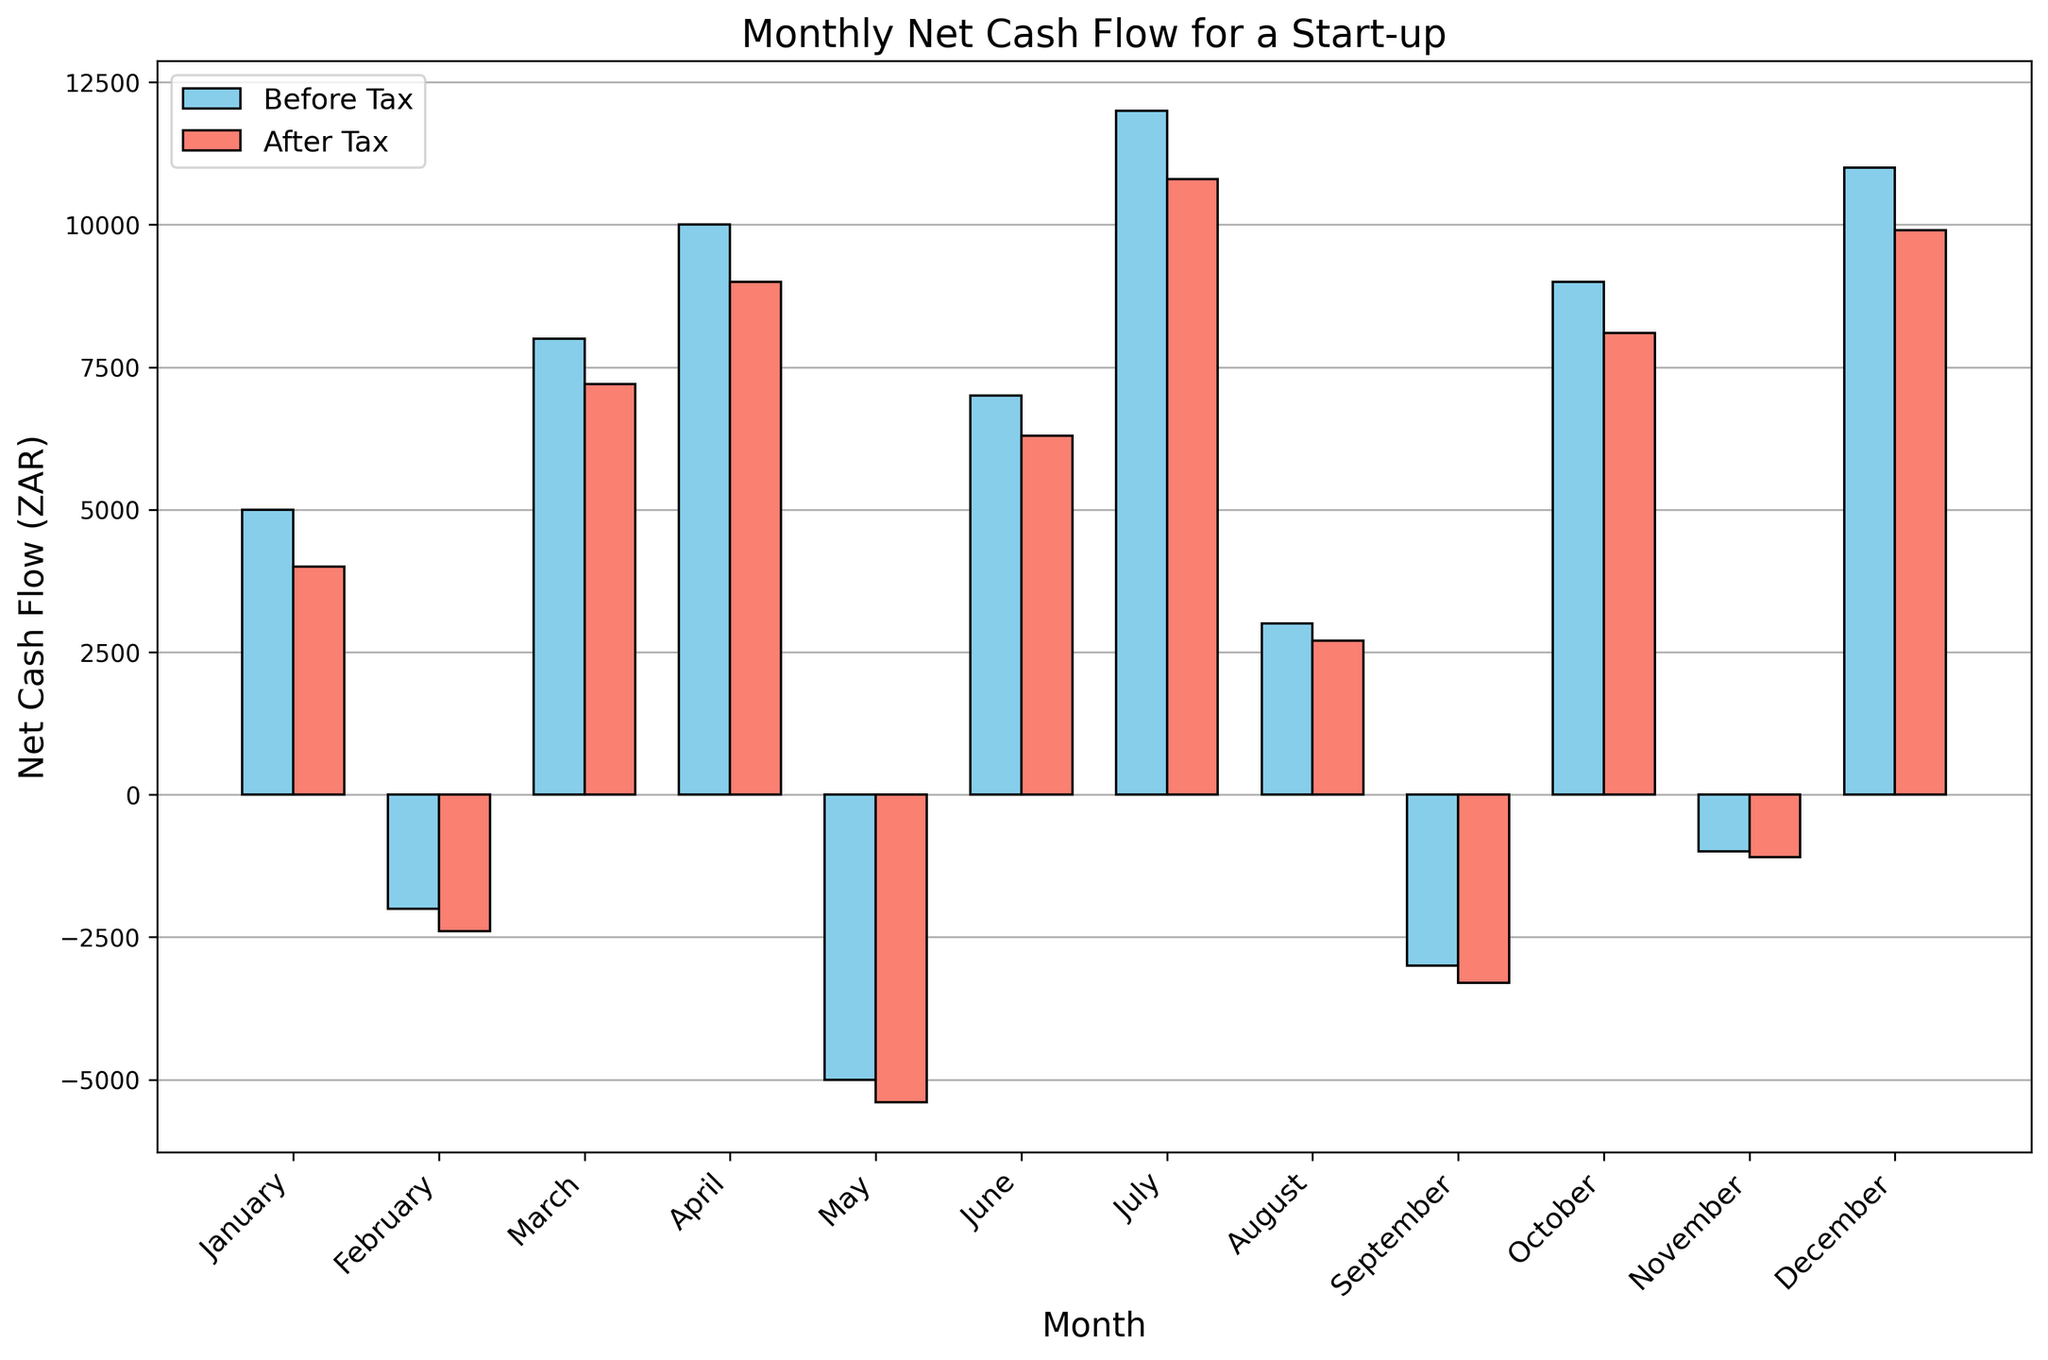Which month has the highest net cash flow after tax? From the figure, the bar representing December has the highest height among the 'After Tax' series.
Answer: December Which months have a negative net cash flow before tax? Checking the bars below zero in the 'Before Tax' series, we see February, May, September, and November have negative values.
Answer: February, May, September, November What is the difference in net cash flow before tax between March and August? The net cash flow in March is 8000 and in August is 3000. The difference is 8000 - 3000.
Answer: 5000 What is the average net cash flow after tax across the year? Sum the 'After Tax' values for each month and divide by the number of months. (4000-2400+7200+9000-5400+6300+10800+2700-3300+8100-1100+9900) / 12.
Answer: 4783.33 Which month showed the most significant improvement after tax adjustments? Calculate the tax difference for each month. The biggest improvement is the smallest negative or the largest positive change between 'Before Tax' and 'After Tax'.
Answer: January (1000) In which month was the difference between net cash flow before and after tax the smallest? Identify the month where the bars' heights for 'Before Tax' and 'After Tax' are closest. November shows the smallest difference.
Answer: November By how much did the net cash flow decrease after tax in April? The net cash flow before tax in April is 10000 and after tax is 9000. The decrease is 10000 - 9000.
Answer: 1000 Which month had a negative net cash flow both before and after tax? By checking the 'Before Tax' and 'After Tax' bars below zero, February and May fit the criteria.
Answer: February, May What is the total net cash flow before tax for the second quarter of the year (April, May, June)? Sum the 'Before Tax' values for April, May, and June. (10000 - 5000 + 7000)
Answer: 12000 How many months have a net cash flow after tax that is less than 3000? Identify the bars below the 3000 mark in the 'After Tax' series: February, May, August, September, November.
Answer: 5 